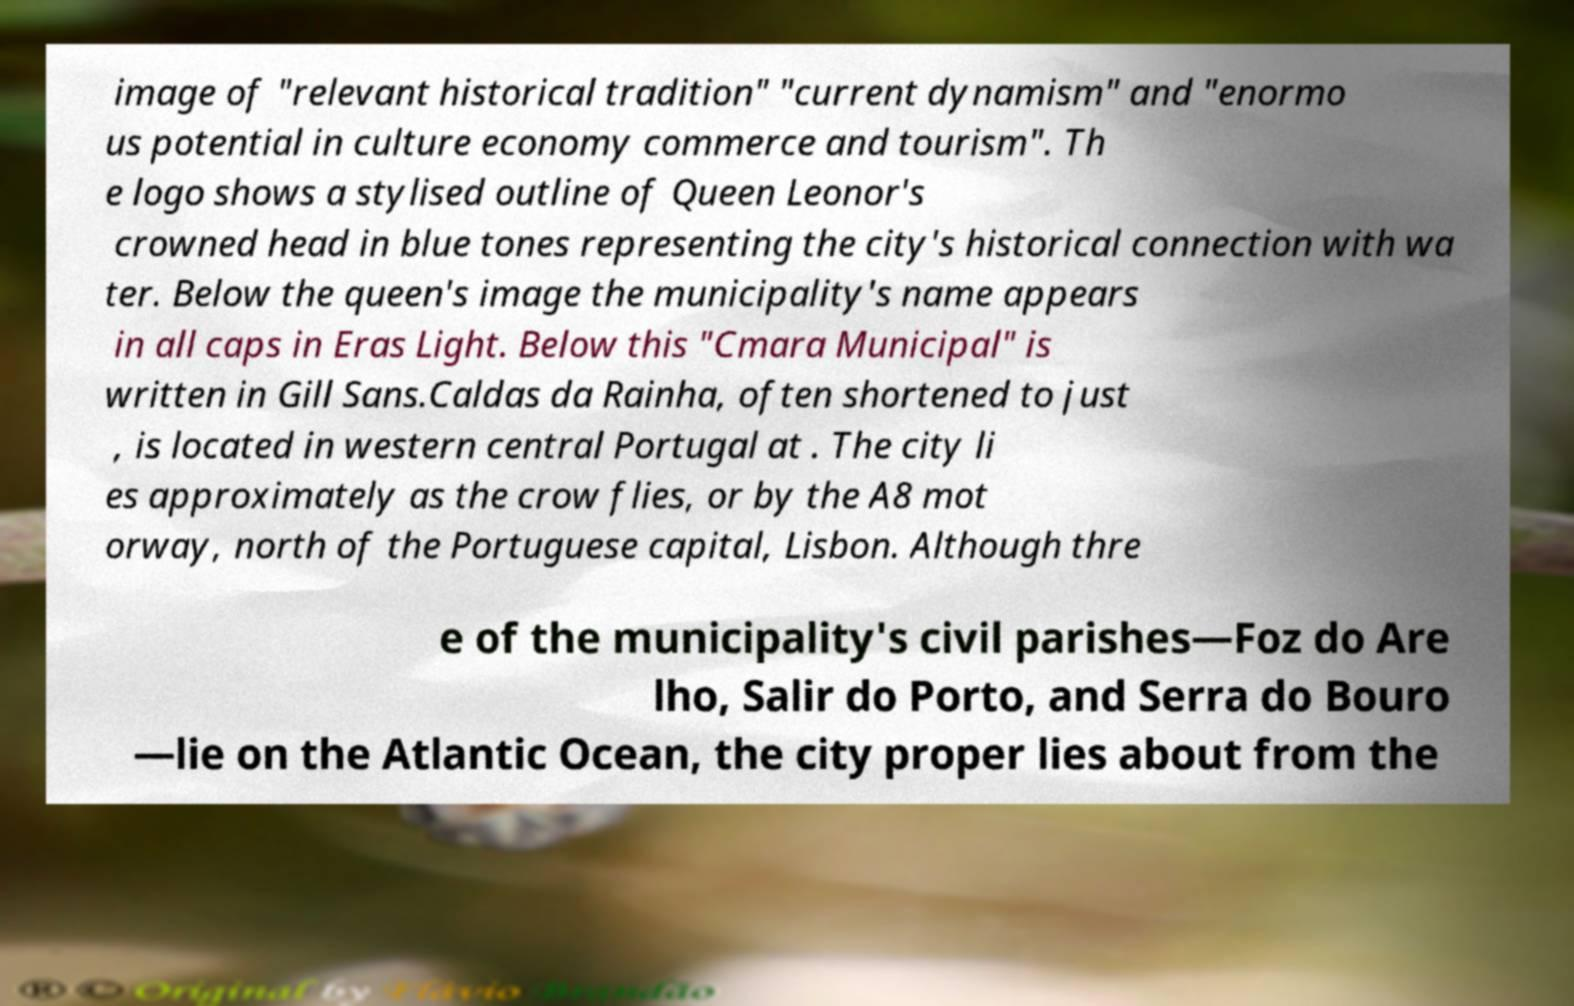Please read and relay the text visible in this image. What does it say? image of "relevant historical tradition" "current dynamism" and "enormo us potential in culture economy commerce and tourism". Th e logo shows a stylised outline of Queen Leonor's crowned head in blue tones representing the city's historical connection with wa ter. Below the queen's image the municipality's name appears in all caps in Eras Light. Below this "Cmara Municipal" is written in Gill Sans.Caldas da Rainha, often shortened to just , is located in western central Portugal at . The city li es approximately as the crow flies, or by the A8 mot orway, north of the Portuguese capital, Lisbon. Although thre e of the municipality's civil parishes—Foz do Are lho, Salir do Porto, and Serra do Bouro —lie on the Atlantic Ocean, the city proper lies about from the 